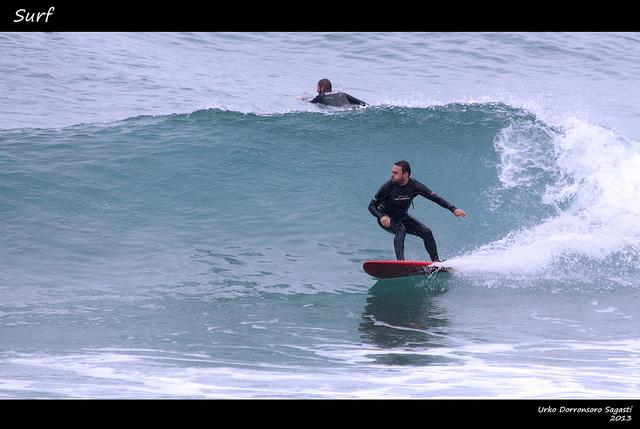Why does the man on the surf board crouch? balance 